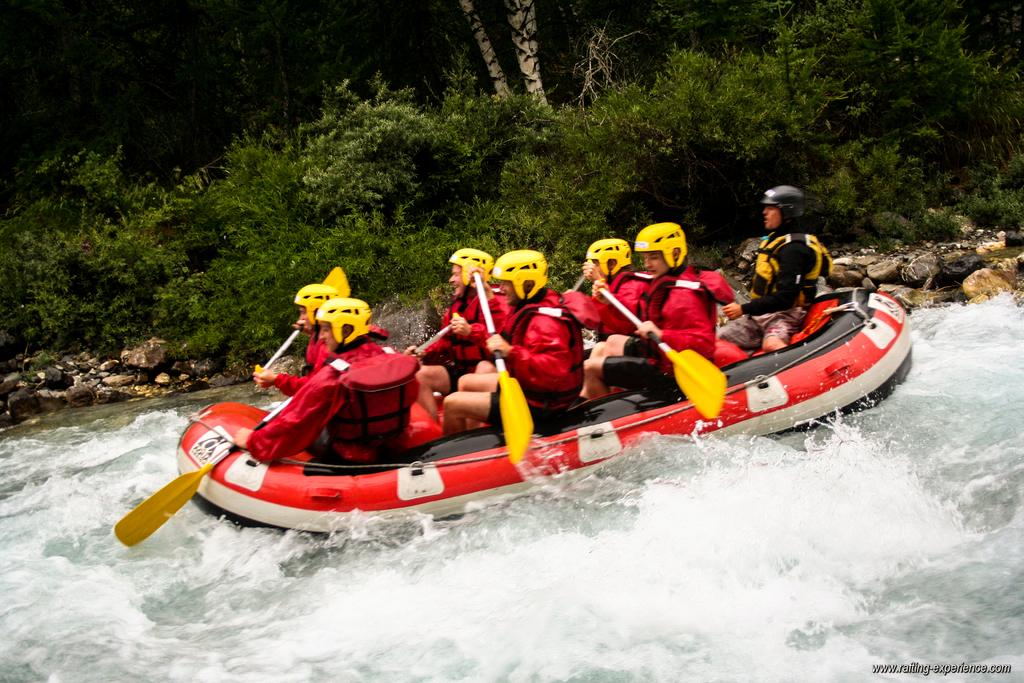What activity are the people in the foreground of the image engaged in? The people in the foreground of the image are boating. Where are the people boating? The people are on the water. What can be seen in the background of the image? There are stones and greenery in the background of the image. Who is the manager of the boating activity in the image? There is no indication of a manager or any supervision in the image. 